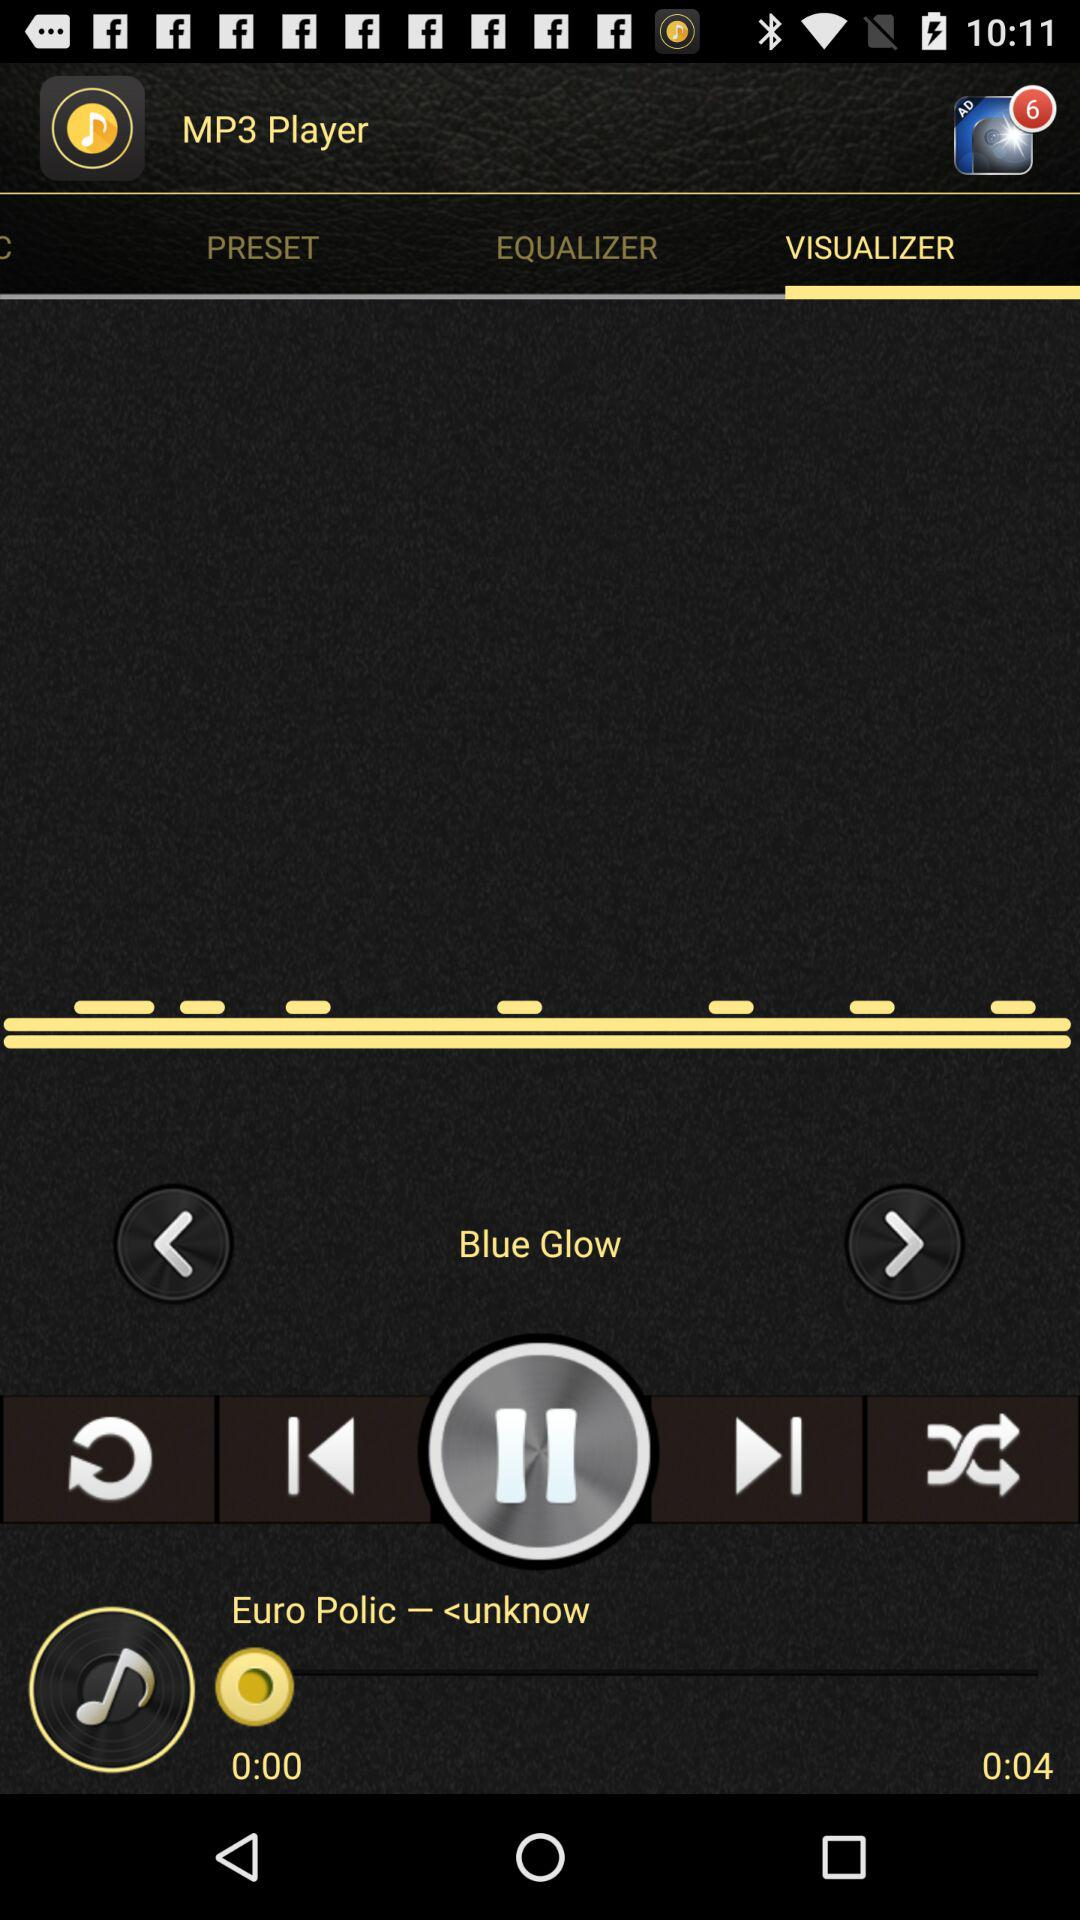What is the length of the currently playing audio? The length of the currently playing audio is 4 seconds. 